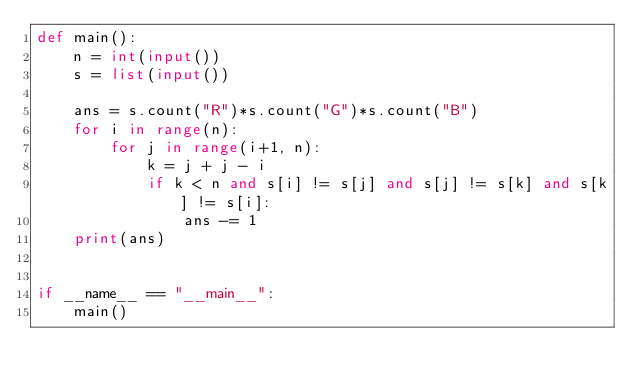Convert code to text. <code><loc_0><loc_0><loc_500><loc_500><_Python_>def main():
    n = int(input())
    s = list(input())

    ans = s.count("R")*s.count("G")*s.count("B")
    for i in range(n):
        for j in range(i+1, n):
            k = j + j - i
            if k < n and s[i] != s[j] and s[j] != s[k] and s[k] != s[i]:
                ans -= 1
    print(ans)


if __name__ == "__main__":
    main()
</code> 